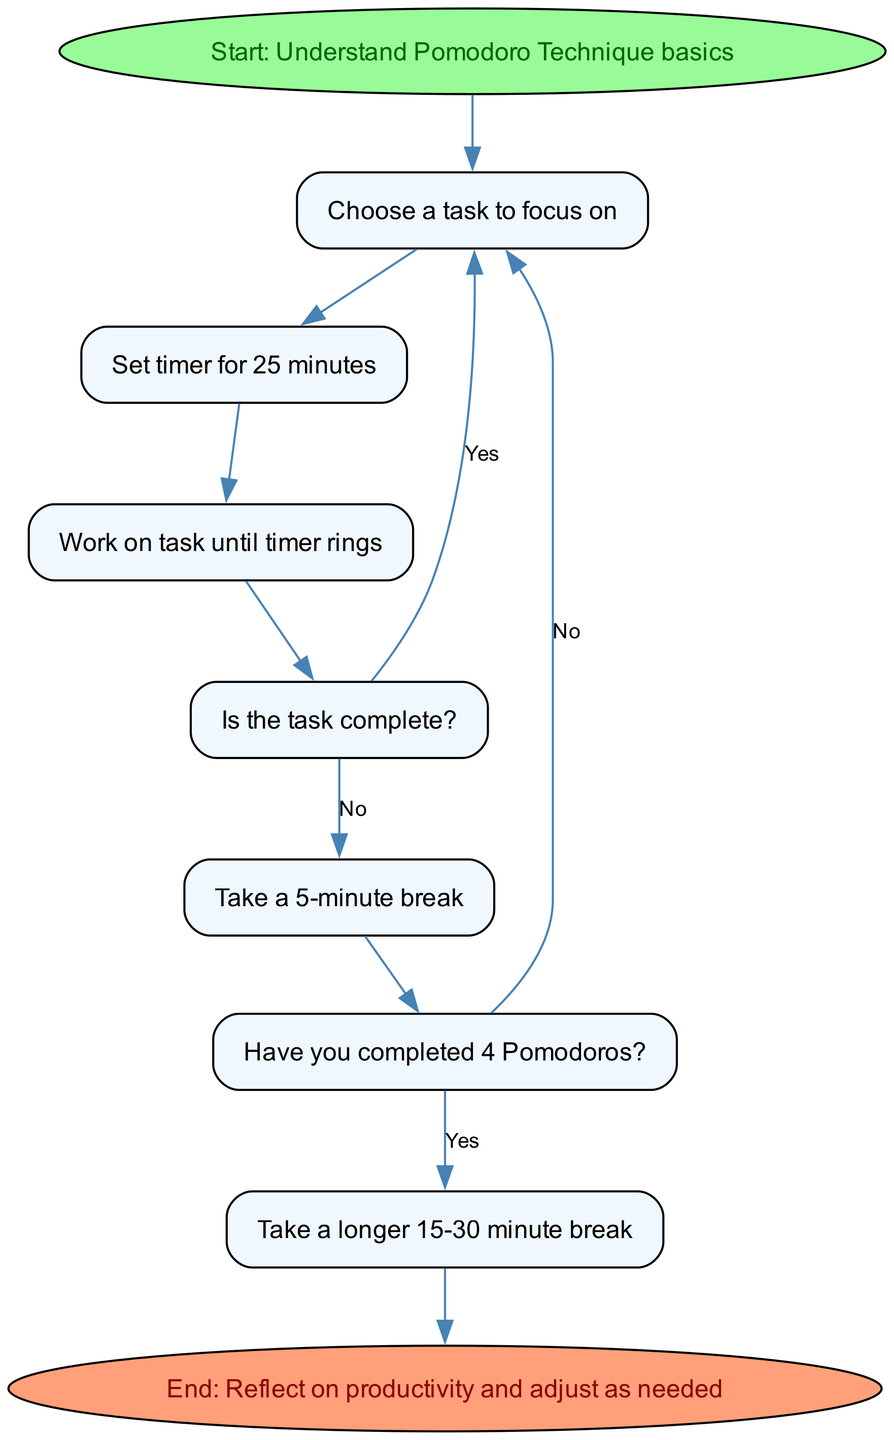What is the first step in the Pomodoro Technique? The first step indicated in the flow chart is "Understand Pomodoro Technique basics." This is the starting point before any task selection can be made.
Answer: Understand Pomodoro Technique basics How many minutes is the timer set for during a Pomodoro? The diagram specifies that the timer should be set for 25 minutes during each Pomodoro. This is a crucial part of the technique, marking focused work time.
Answer: 25 minutes What do you do after the timer rings? After the timer rings, the next action is to check if the task is complete. This is indicated by the decision node that follows the work period.
Answer: Check if the task is complete What happens if the task is complete after working for 25 minutes? If the task is complete, the flow chart directs you back to choose another task, indicating a continuous cycle of work rather than a break.
Answer: Choose another task What is the duration of the short break? According to the diagram, after each Pomodoro, you should take a short break of 5 minutes. This allows for recovery before the next work session.
Answer: 5 minutes What should you do after completing four Pomodoros? Once you have completed four Pomodoros, the flow chart states that you should take a longer break, ranging from 15-30 minutes, to rest and recharge.
Answer: Take a longer 15-30 minute break What shape represents decision points in the diagram? The decision points in the flow chart are represented by diamond shapes. These indicate moments where a choice must be made, such as whether the task is complete.
Answer: Diamond How many steps are there in the overall process, excluding decision points? By counting the main step nodes (excluding decision nodes), we find a total of five steps: understanding basics, choosing a task, setting the timer, working on the task, and taking a break.
Answer: Five steps What do you evaluate at the end of the process? At the end of the process, the diagram suggests reflecting on productivity and adjusting as needed, emphasizing the importance of continuous improvement in time management.
Answer: Reflect on productivity and adjust as needed 